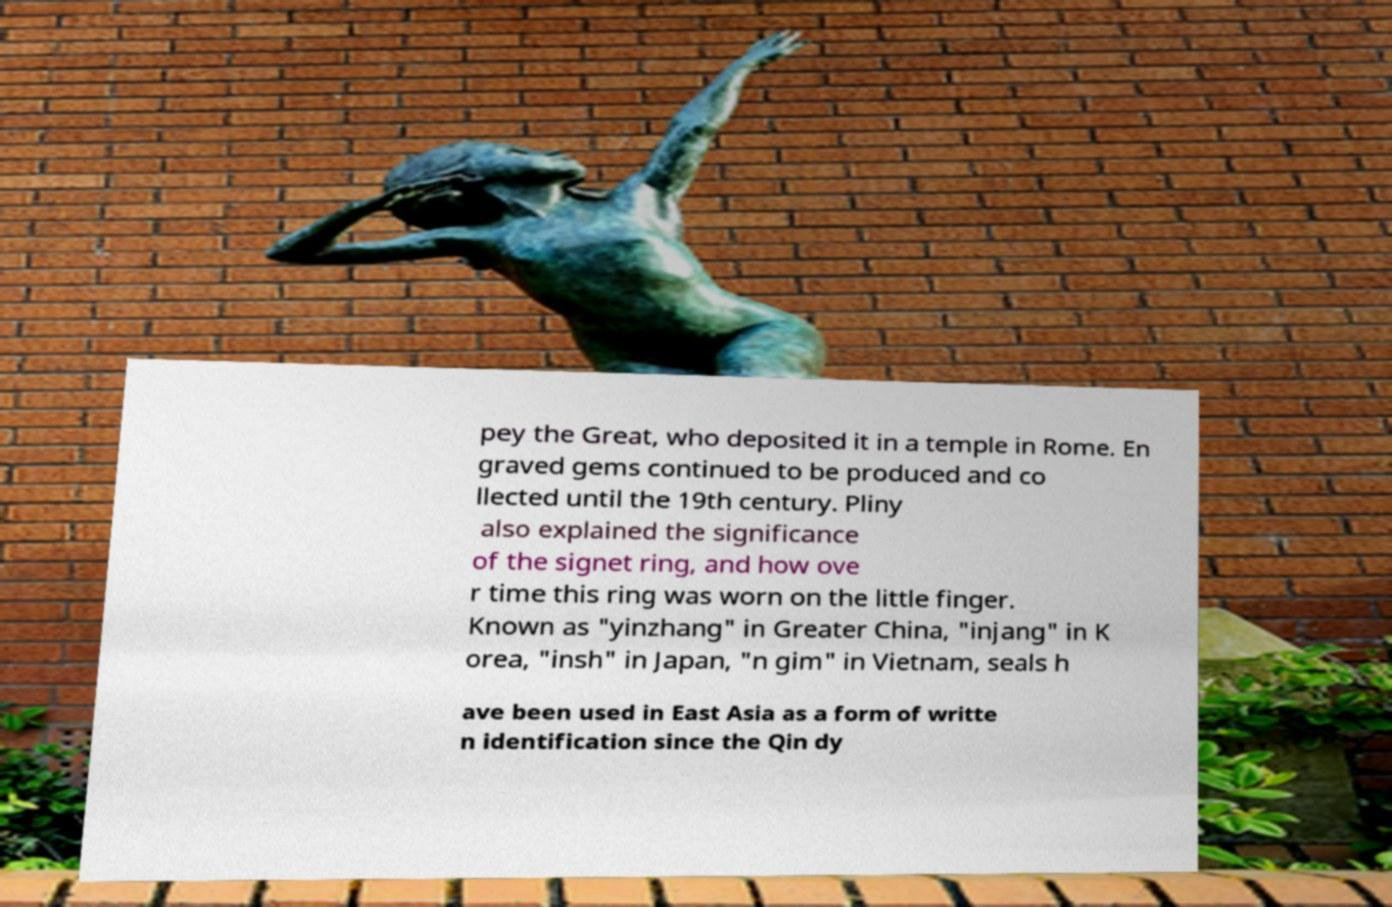Please read and relay the text visible in this image. What does it say? pey the Great, who deposited it in a temple in Rome. En graved gems continued to be produced and co llected until the 19th century. Pliny also explained the significance of the signet ring, and how ove r time this ring was worn on the little finger. Known as "yinzhang" in Greater China, "injang" in K orea, "insh" in Japan, "n gim" in Vietnam, seals h ave been used in East Asia as a form of writte n identification since the Qin dy 